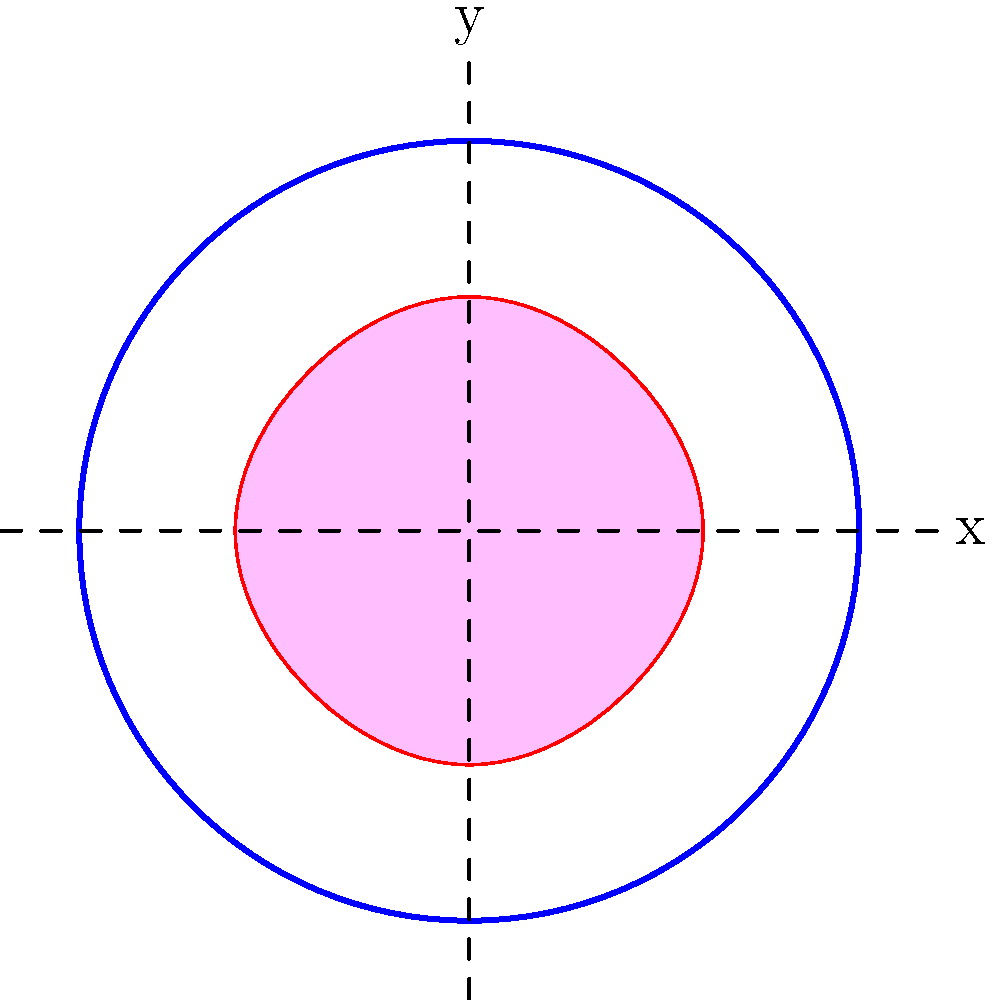As a marketing professional designing a logo for a new candy brand, you're presented with the above symmetrical shape. How many lines of symmetry does this candy-shaped logo have? To determine the number of lines of symmetry for this candy-shaped logo, let's follow these steps:

1. Observe the shape: The logo is a stylized candy shape inscribed within a circle.

2. Identify vertical symmetry: The shape is symmetrical along the vertical y-axis. If folded along this line, both halves would match perfectly.

3. Identify horizontal symmetry: The shape is also symmetrical along the horizontal x-axis. Folding along this line would result in matching top and bottom halves.

4. Check for diagonal symmetry: Upon careful inspection, we can see that the shape is also symmetrical along two diagonal lines that would run from top-left to bottom-right and top-right to bottom-left at 45-degree angles to the x and y axes.

5. Count the lines of symmetry: We have identified four lines of symmetry:
   - 1 vertical line (y-axis)
   - 1 horizontal line (x-axis)
   - 2 diagonal lines (at 45-degree angles)

Therefore, the total number of lines of symmetry for this candy-shaped logo is 4.

This high degree of symmetry can be beneficial for a candy logo as it creates a balanced, visually appealing design that's easy to recognize and remember, which are important factors in successful branding and marketing campaigns.
Answer: 4 lines of symmetry 